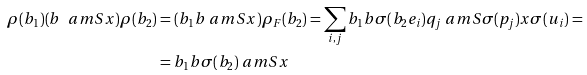<formula> <loc_0><loc_0><loc_500><loc_500>\rho ( b _ { 1 } ) ( b \ a m { S } x ) \rho ( b _ { 2 } ) & = ( b _ { 1 } b \ a m { S } x ) \rho _ { F } ( b _ { 2 } ) = \sum _ { i , j } b _ { 1 } b \sigma ( b _ { 2 } e _ { i } ) q _ { j } \ a m { S } \sigma ( p _ { j } ) x \sigma ( u _ { i } ) = \\ & = b _ { 1 } b \sigma ( b _ { 2 } ) \ a m { S } x</formula> 